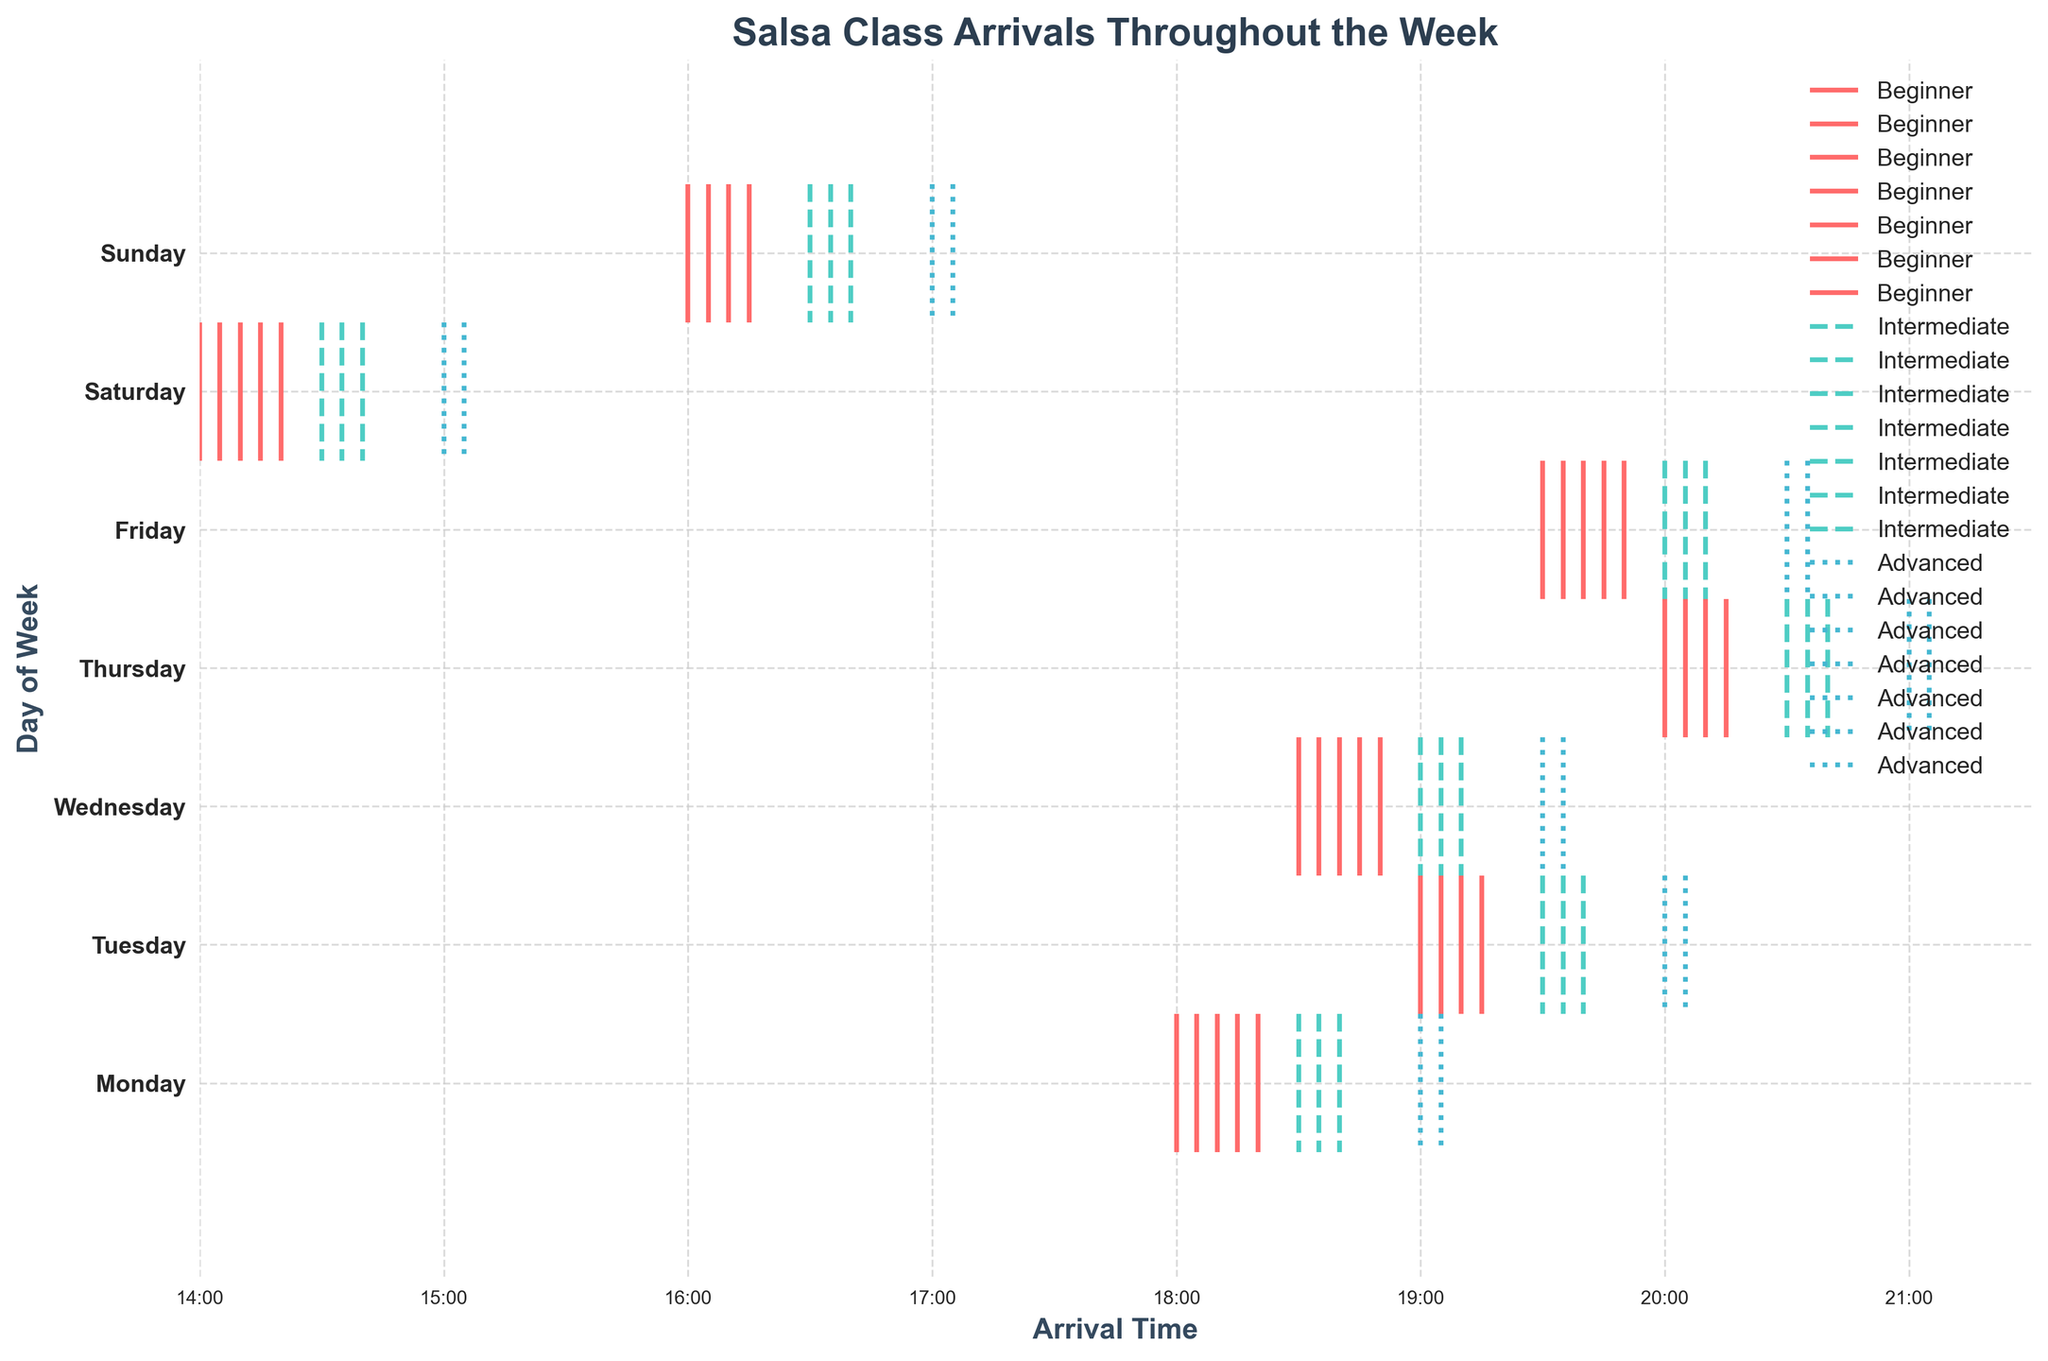What is the title of the figure? The title is displayed at the top of the figure and reads 'Salsa Class Arrivals Throughout the Week'.
Answer: Salsa Class Arrivals Throughout the Week Which day has participant arrivals starting the earliest? By comparing the earliest arrival times on each day, Saturday has the earliest arrival times starting at 14:00.
Answer: Saturday How do the arrival patterns of advanced participants on Monday compare to Friday? On Monday, advanced participants arrive between 19:00 and 19:05. On Friday, advanced participants arrive between 20:30 and 20:35. Thus, Friday arrivals are later than Monday.
Answer: Later on Friday What visual elements indicate different skill levels on the plot? The eventplot uses different colors and linestyles for each skill level: red solid for beginners, teal dashed for intermediate, and blue dotted for advanced.
Answer: Colors and linestyles Which skill level shows the most consistent arrival times throughout the week? Intermediate participants have the most consistent arrival times, generally occurring within a narrow window (typically around 19:30 to 20:40) across different days.
Answer: Intermediate What are the latest arrival times shown in this figure, and on which day do they occur? The latest arrival times are 21:00 and 21:05, occurring on Thursday for advanced participants.
Answer: 21:00 and 21:05 on Thursday Do beginners on Wednesday arrive earlier or later than beginners on Thursday? On Wednesday, beginners arrive at around 18:30-18:50, whereas on Thursday, they arrive around 20:00-20:15. Therefore, beginners on Wednesday arrive earlier than on Thursday.
Answer: Earlier on Wednesday Compare the range of arrival times for intermediate participants on Friday versus Saturday. Intermediate participants on Friday arrive between 20:00 and 20:10, whereas on Saturday, they arrive between 14:30 and 14:40. Arrival times on Saturday are earlier than on Friday.
Answer: Earlier on Saturday Is there a day where all participant skill levels have arrivals within a 1-hour window? On Saturday, beginners, intermediates, and advanced participants all have arrivals between 14:00 and 15:05, which is within a 1-hour window.
Answer: Yes, on Saturday Which day has the highest concentration of beginner arrivals in the evening? By observing the data points, Monday has the highest concentration of beginner arrivals clustered around 18:00-18:20 in the evening.
Answer: Monday 